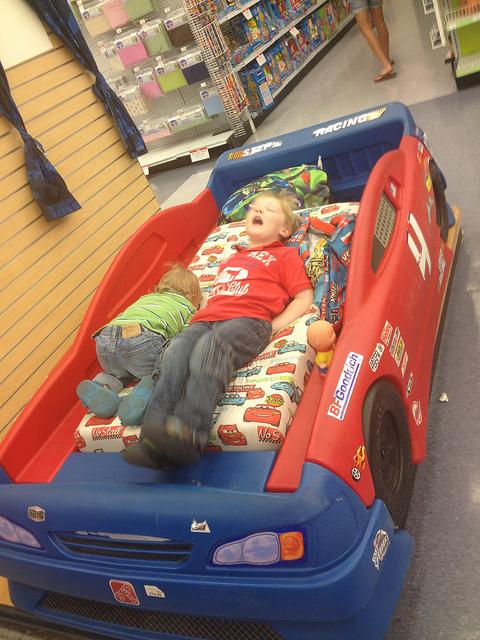What number is on the car?
Quick response, please. 4. What is this child doing?
Answer briefly. Sleeping. Is this child asleep?
Quick response, please. No. What is the bed's design?
Quick response, please. Car. 